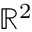<formula> <loc_0><loc_0><loc_500><loc_500>\mathbb { R } ^ { 2 }</formula> 